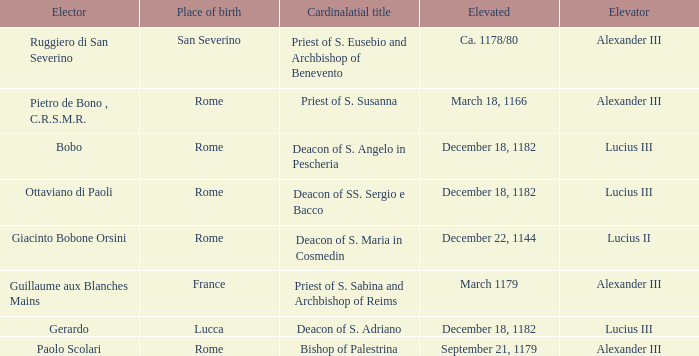What is the Elevator of the Elected Elevated on September 21, 1179? Alexander III. 